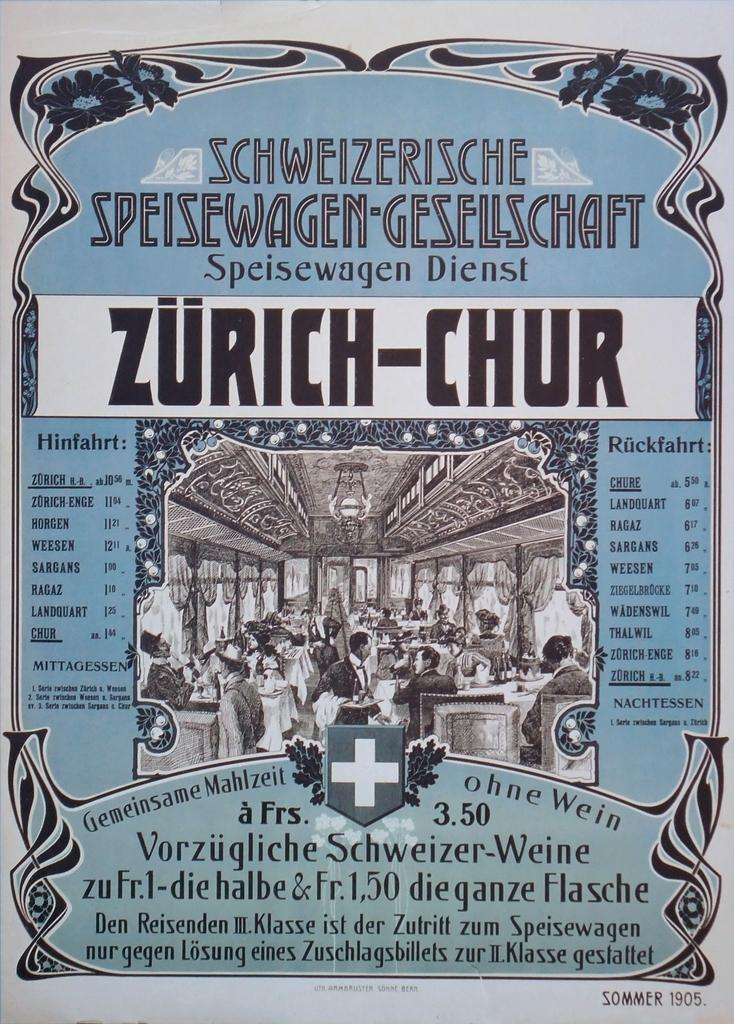<image>
Give a short and clear explanation of the subsequent image. The poster from summer of 1905 announces Zurich-Chur. 